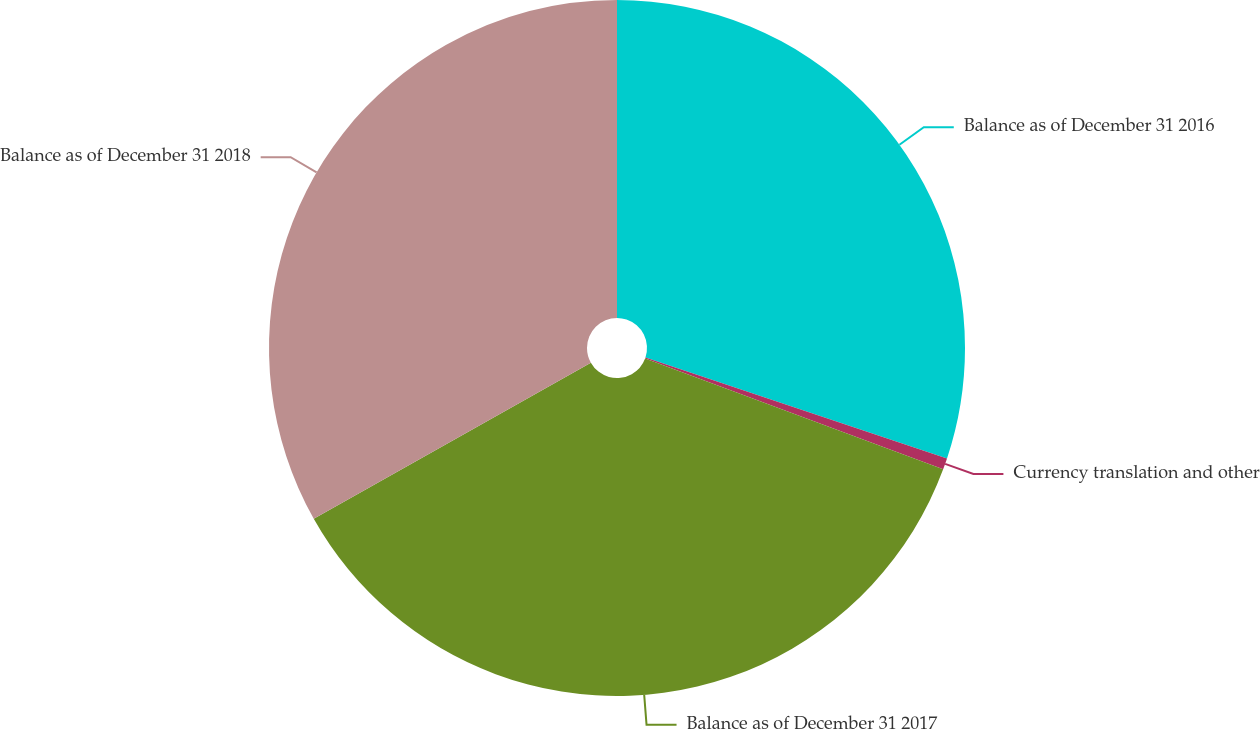Convert chart to OTSL. <chart><loc_0><loc_0><loc_500><loc_500><pie_chart><fcel>Balance as of December 31 2016<fcel>Currency translation and other<fcel>Balance as of December 31 2017<fcel>Balance as of December 31 2018<nl><fcel>30.14%<fcel>0.53%<fcel>36.17%<fcel>33.16%<nl></chart> 